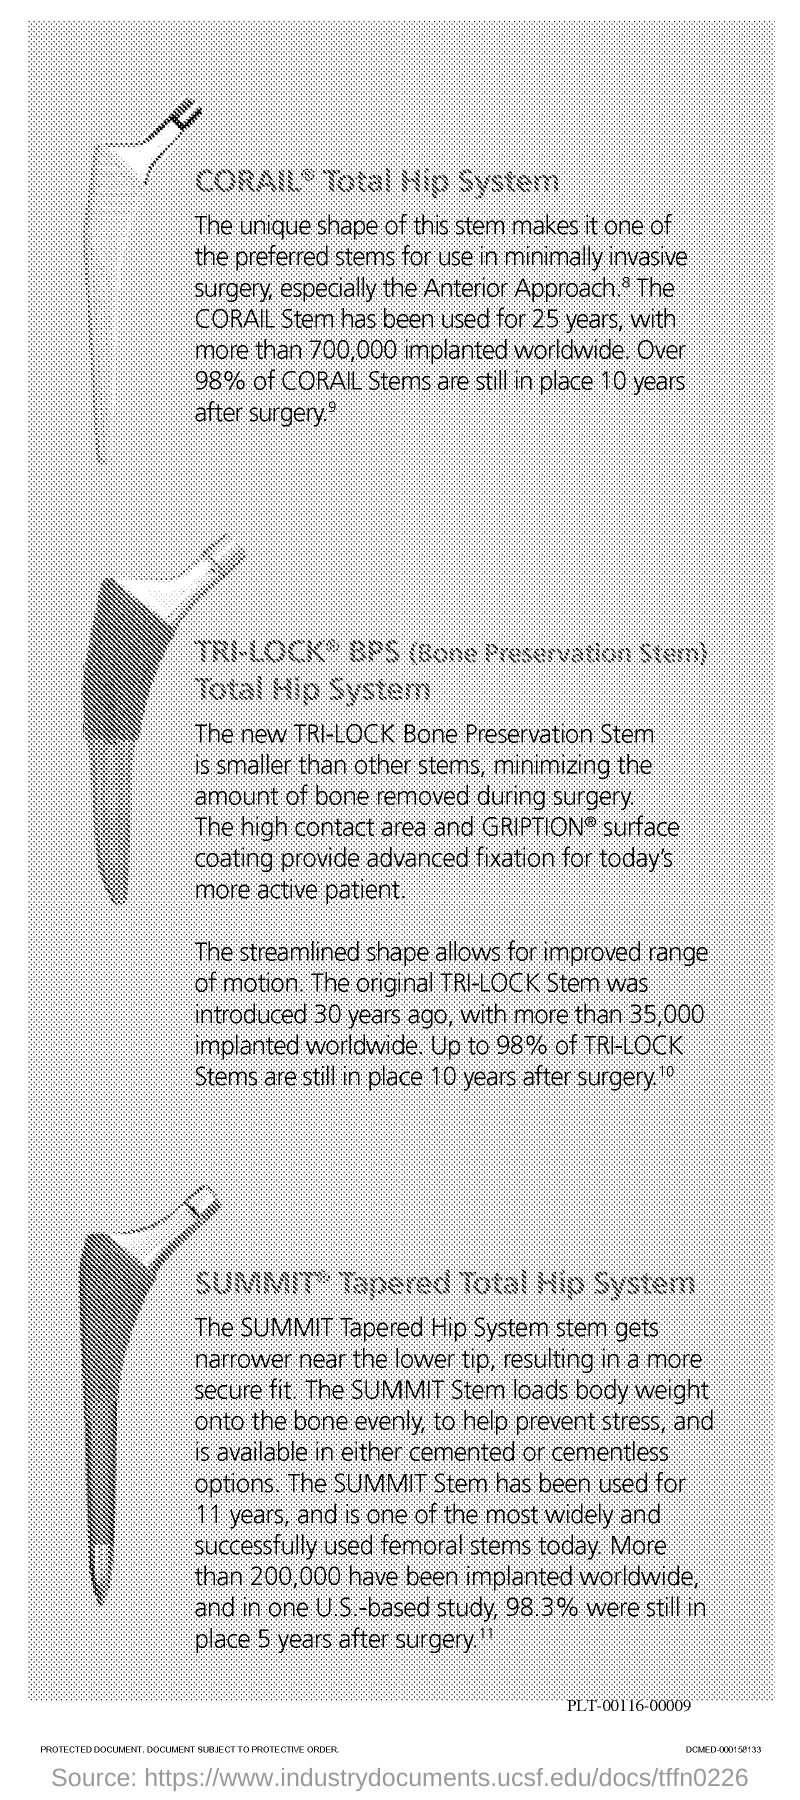Give some essential details in this illustration. It is estimated that approximately 700,000 implants have been installed worldwide. The CORAIL Stem has been in use for 25 years. Ninety-eight percent of CORAIL stems have been installed. 